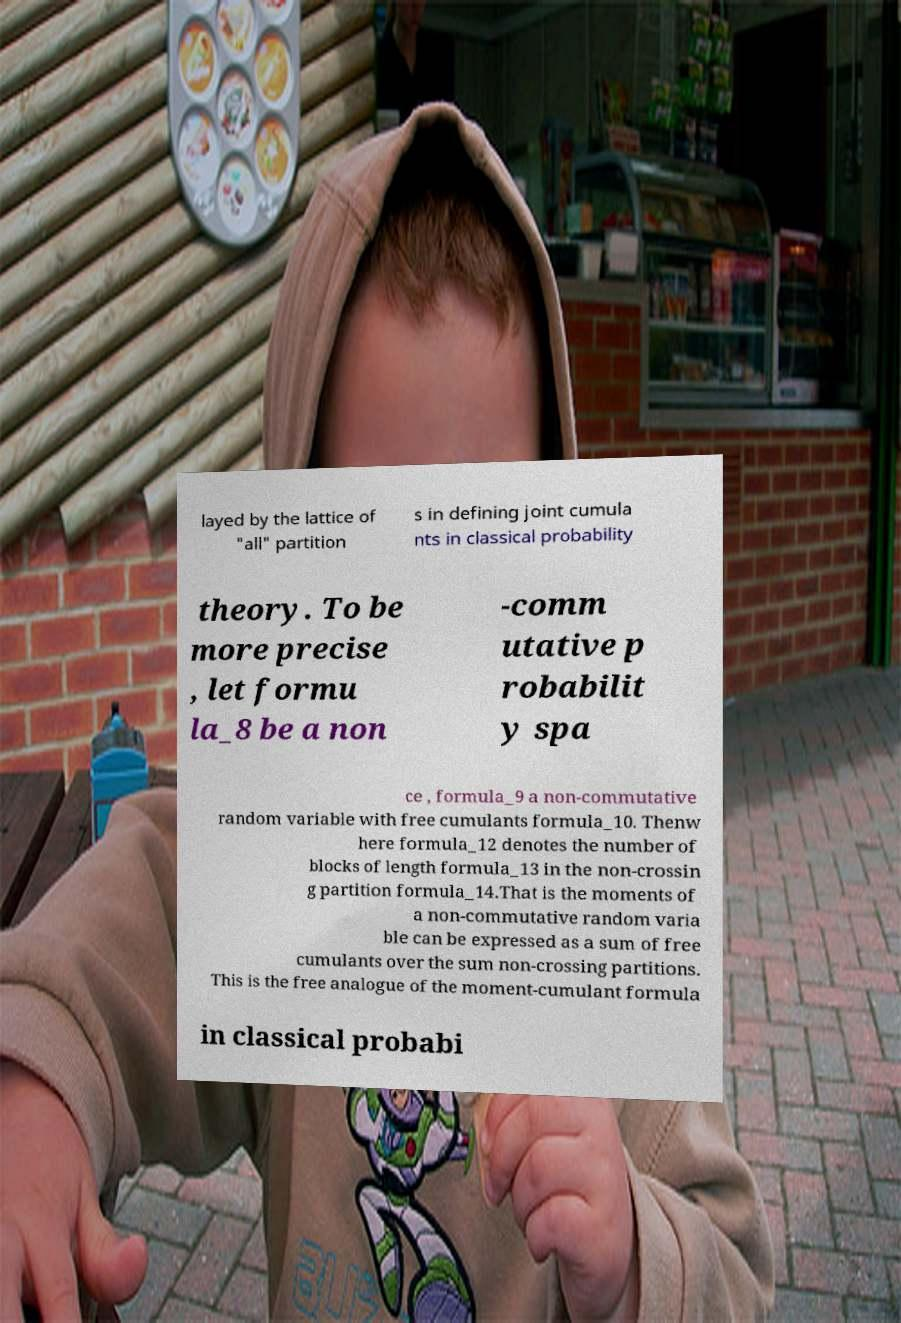Can you accurately transcribe the text from the provided image for me? layed by the lattice of "all" partition s in defining joint cumula nts in classical probability theory. To be more precise , let formu la_8 be a non -comm utative p robabilit y spa ce , formula_9 a non-commutative random variable with free cumulants formula_10. Thenw here formula_12 denotes the number of blocks of length formula_13 in the non-crossin g partition formula_14.That is the moments of a non-commutative random varia ble can be expressed as a sum of free cumulants over the sum non-crossing partitions. This is the free analogue of the moment-cumulant formula in classical probabi 